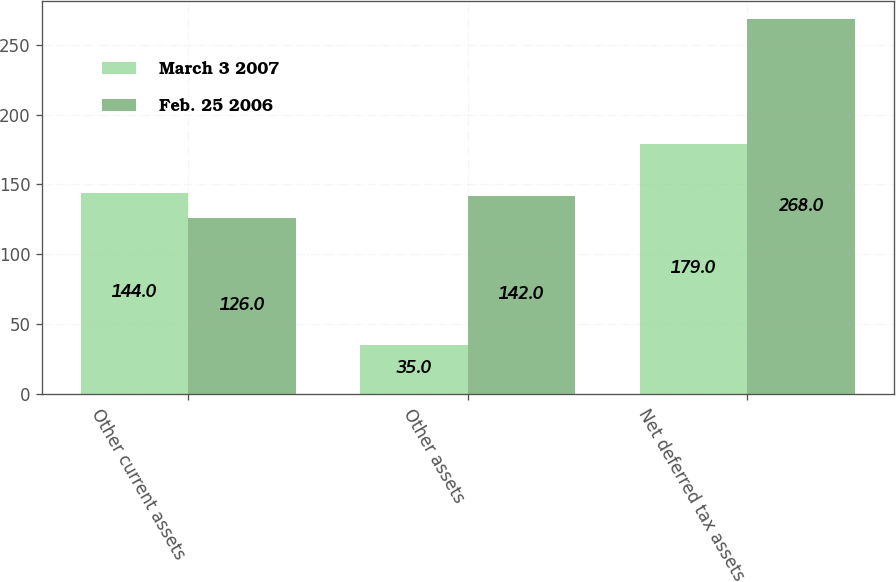Convert chart to OTSL. <chart><loc_0><loc_0><loc_500><loc_500><stacked_bar_chart><ecel><fcel>Other current assets<fcel>Other assets<fcel>Net deferred tax assets<nl><fcel>March 3 2007<fcel>144<fcel>35<fcel>179<nl><fcel>Feb. 25 2006<fcel>126<fcel>142<fcel>268<nl></chart> 